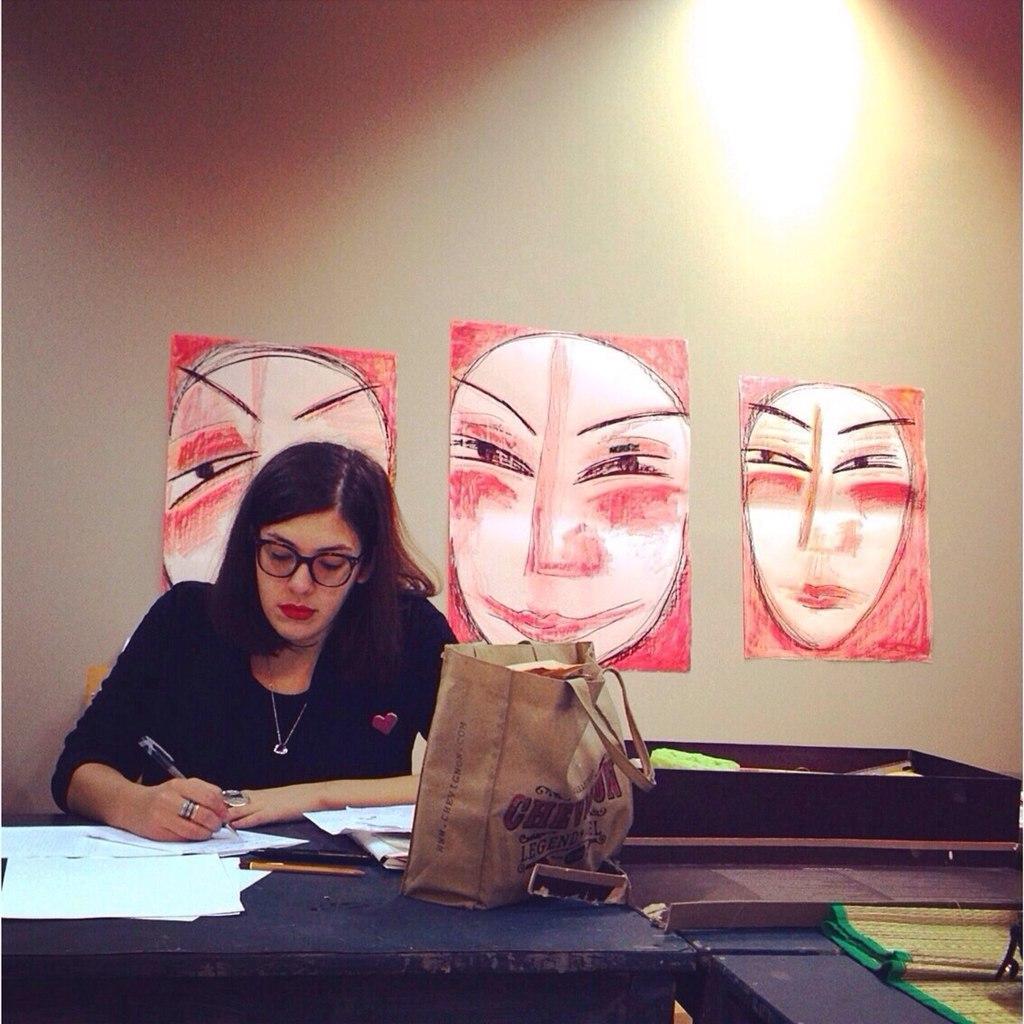Please provide a concise description of this image. This is the Picture of a lady who is sitting on the chair in front of the table and on the table we have some papers and a bag and behind her there are three posters. 